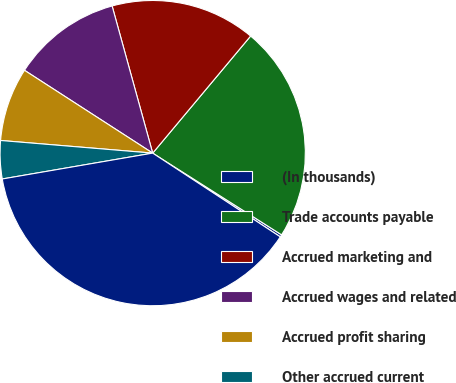Convert chart to OTSL. <chart><loc_0><loc_0><loc_500><loc_500><pie_chart><fcel>(In thousands)<fcel>Trade accounts payable<fcel>Accrued marketing and<fcel>Accrued wages and related<fcel>Accrued profit sharing<fcel>Other accrued current<fcel>Total<nl><fcel>0.25%<fcel>22.91%<fcel>15.37%<fcel>11.59%<fcel>7.81%<fcel>4.03%<fcel>38.05%<nl></chart> 